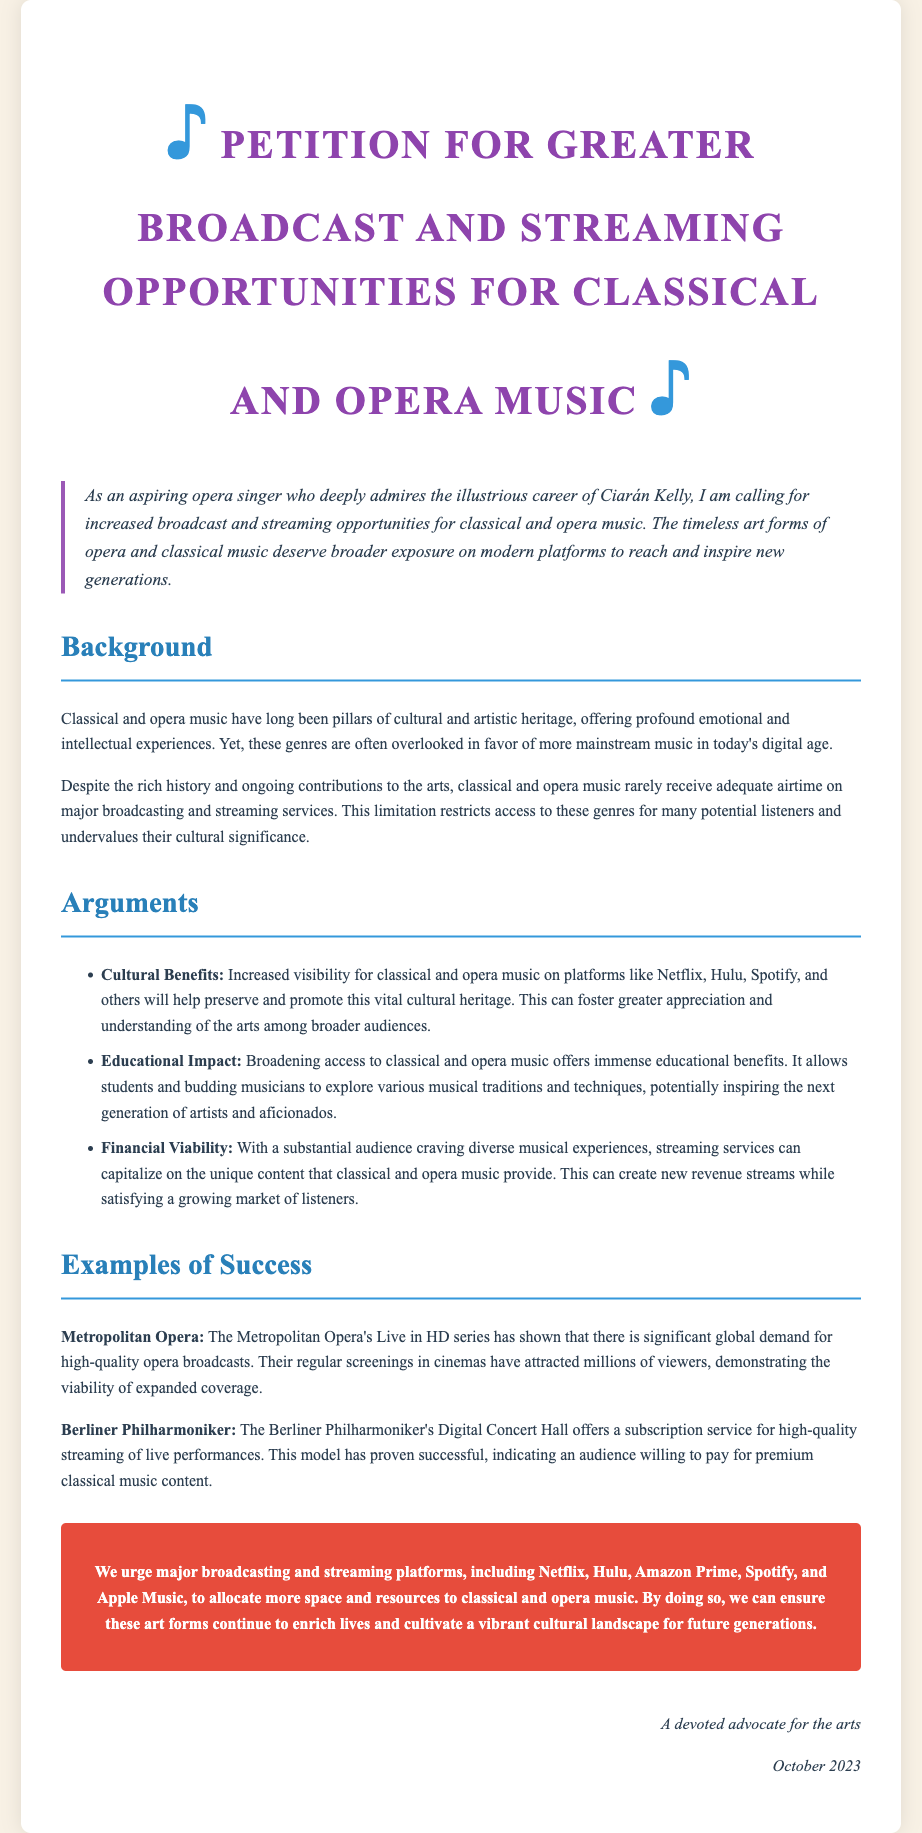What is the primary aim of the petition? The petition calls for increased broadcast and streaming opportunities for classical and opera music.
Answer: Increased broadcast and streaming opportunities for classical and opera music Who is the petition directed towards? The petition urges major broadcasting and streaming platforms like Netflix, Hulu, Amazon Prime, Spotify, and Apple Music.
Answer: Major broadcasting and streaming platforms What event has shown global demand for high-quality opera broadcasts? The Metropolitan Opera's Live in HD series has demonstrated significant global demand.
Answer: Metropolitan Opera's Live in HD series What is one educational benefit mentioned in the petition? Broadening access to classical and opera music allows students and budding musicians to explore various musical traditions and techniques.
Answer: Educational benefits What subscription service is provided by the Berliner Philharmoniker? The Berliner Philharmoniker offers a Digital Concert Hall subscription service for high-quality streaming.
Answer: Digital Concert Hall What is the date of the petition? The petition was signed in October 2023.
Answer: October 2023 What is the significance of the cultural benefit associated with increased visibility for classical and opera music? It helps preserve and promote this vital cultural heritage and fosters appreciation among broader audiences.
Answer: Cultural heritage preservation and appreciation How does the petition view the relationship between streaming services and classical music? Streaming services can capitalize on the unique content that classical and opera music provide, creating new revenue streams.
Answer: New revenue streams 